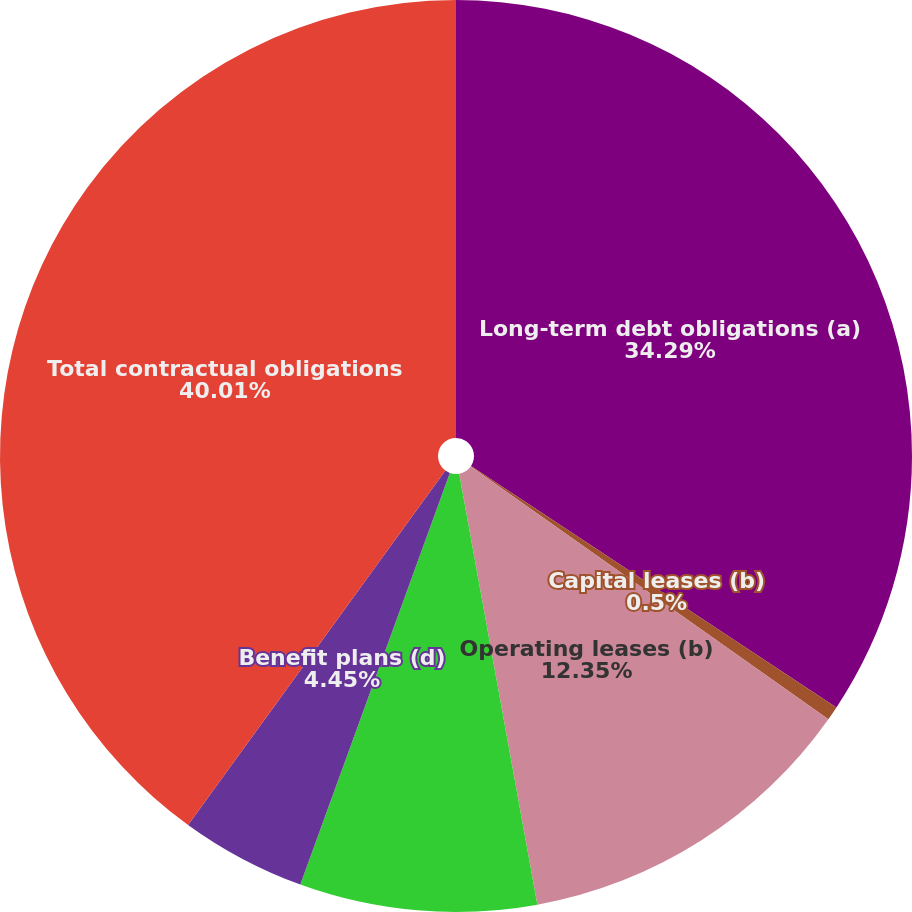<chart> <loc_0><loc_0><loc_500><loc_500><pie_chart><fcel>Long-term debt obligations (a)<fcel>Capital leases (b)<fcel>Operating leases (b)<fcel>Purchase obligations (c)<fcel>Benefit plans (d)<fcel>Total contractual obligations<nl><fcel>34.29%<fcel>0.5%<fcel>12.35%<fcel>8.4%<fcel>4.45%<fcel>40.0%<nl></chart> 